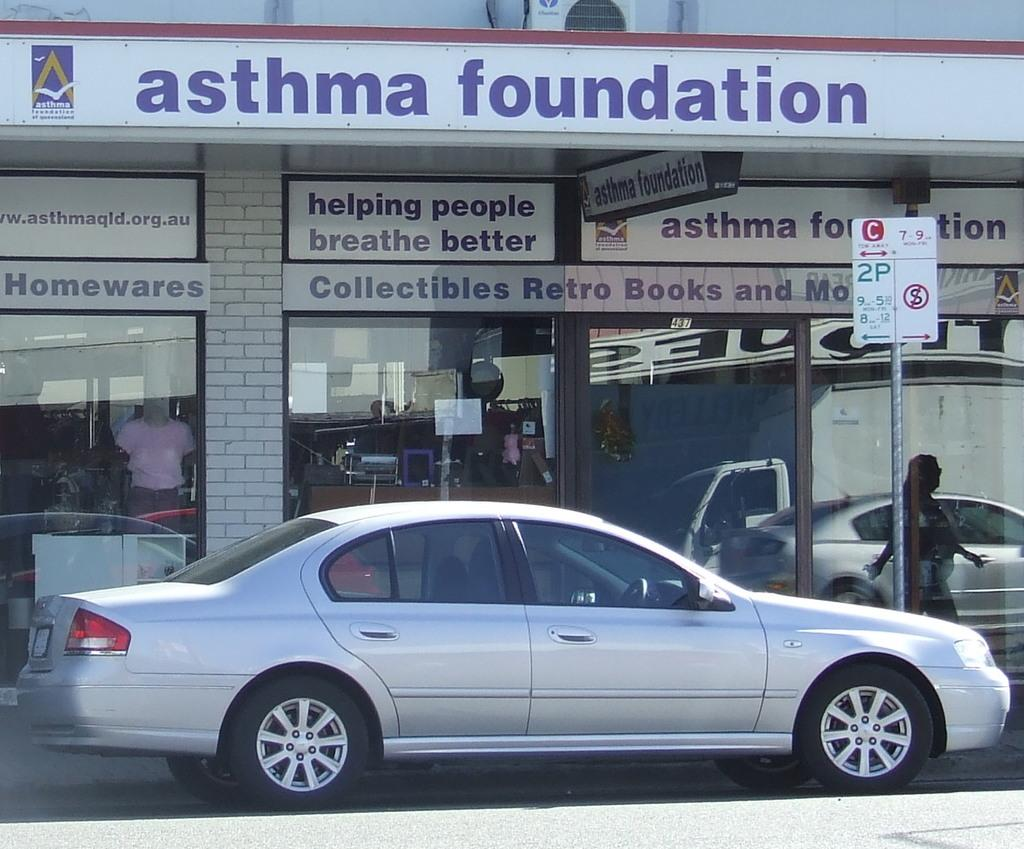What type of structure is visible in the image? There is a building in the image. What mode of transportation can be seen in the image? There is a car in the image. What surface is visible in the image? There is a road in the image. What additional information is provided on the road? There is a sign board in the image. How many bags of salt are visible in the image? There is no salt present in the image. What type of bird can be seen flying near the building in the image? There is no bird present in the image. 